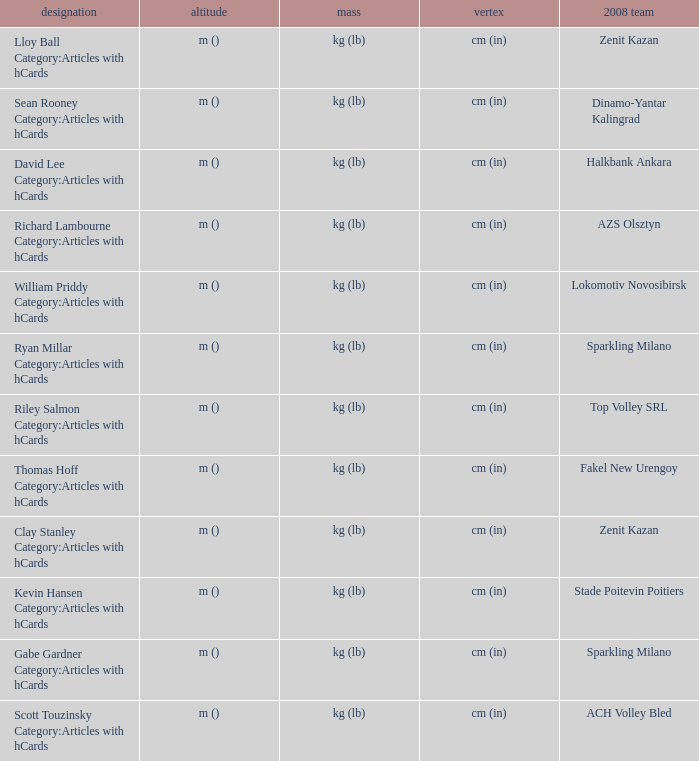What name has Fakel New Urengoy as the 2008 club? Thomas Hoff Category:Articles with hCards. 